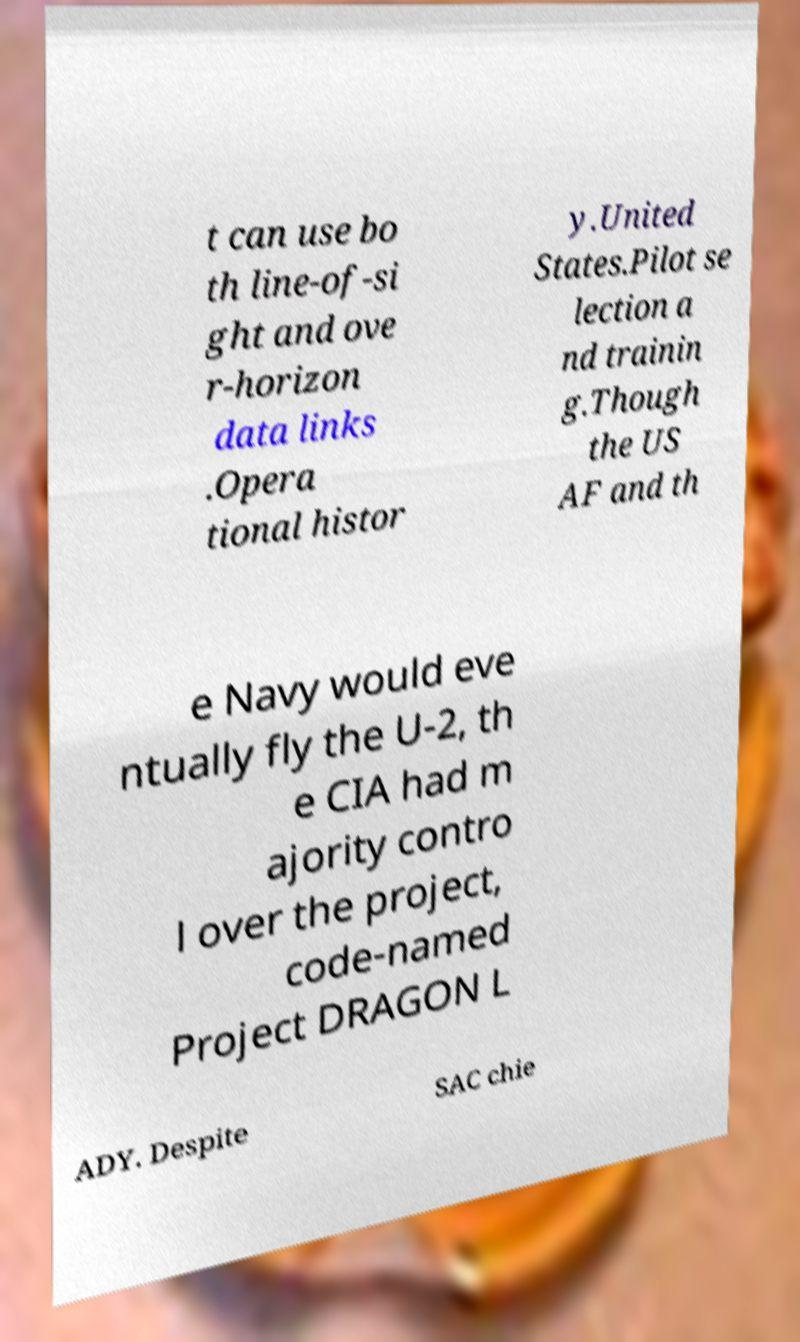I need the written content from this picture converted into text. Can you do that? t can use bo th line-of-si ght and ove r-horizon data links .Opera tional histor y.United States.Pilot se lection a nd trainin g.Though the US AF and th e Navy would eve ntually fly the U-2, th e CIA had m ajority contro l over the project, code-named Project DRAGON L ADY. Despite SAC chie 